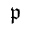Convert formula to latex. <formula><loc_0><loc_0><loc_500><loc_500>\mathfrak { p }</formula> 